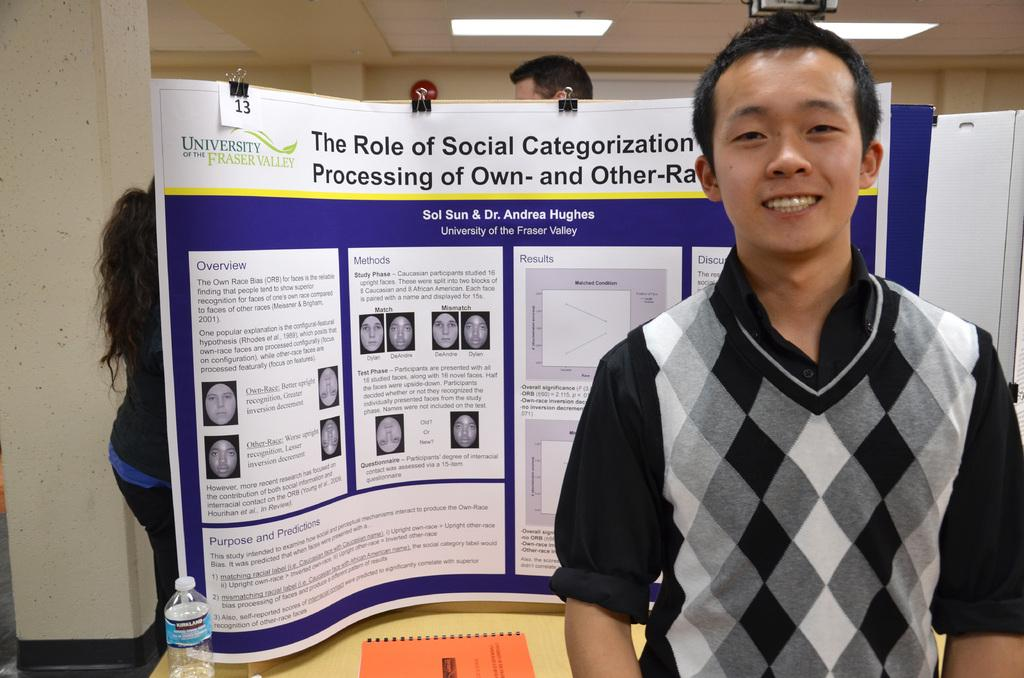Provide a one-sentence caption for the provided image. Man presents his thesis at a medical conference. 